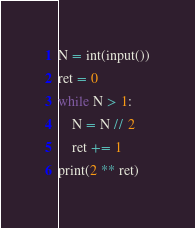<code> <loc_0><loc_0><loc_500><loc_500><_Python_>N = int(input())
ret = 0
while N > 1:
    N = N // 2
    ret += 1
print(2 ** ret)</code> 